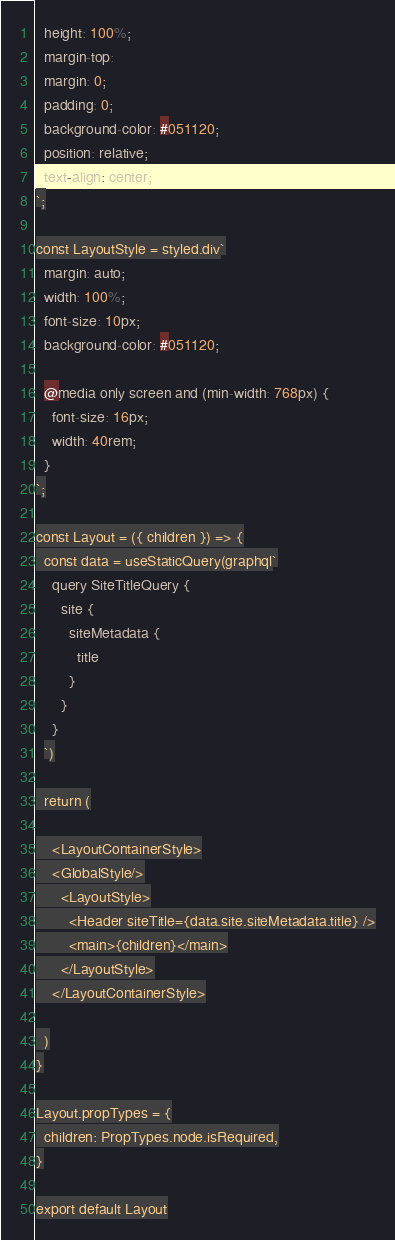<code> <loc_0><loc_0><loc_500><loc_500><_JavaScript_>  height: 100%;
  margin-top:
  margin: 0;
  padding: 0;
  background-color: #051120;
  position: relative;
  text-align: center;
`;

const LayoutStyle = styled.div`
  margin: auto;
  width: 100%;
  font-size: 10px;
  background-color: #051120;

  @media only screen and (min-width: 768px) {
    font-size: 16px;
    width: 40rem;
  }
`;

const Layout = ({ children }) => {
  const data = useStaticQuery(graphql`
    query SiteTitleQuery {
      site {
        siteMetadata {
          title
        }
      }
    }
  `)

  return (

    <LayoutContainerStyle>
    <GlobalStyle/>
      <LayoutStyle>
        <Header siteTitle={data.site.siteMetadata.title} />
        <main>{children}</main>
      </LayoutStyle>
    </LayoutContainerStyle>

  )
}

Layout.propTypes = {
  children: PropTypes.node.isRequired,
}

export default Layout
</code> 